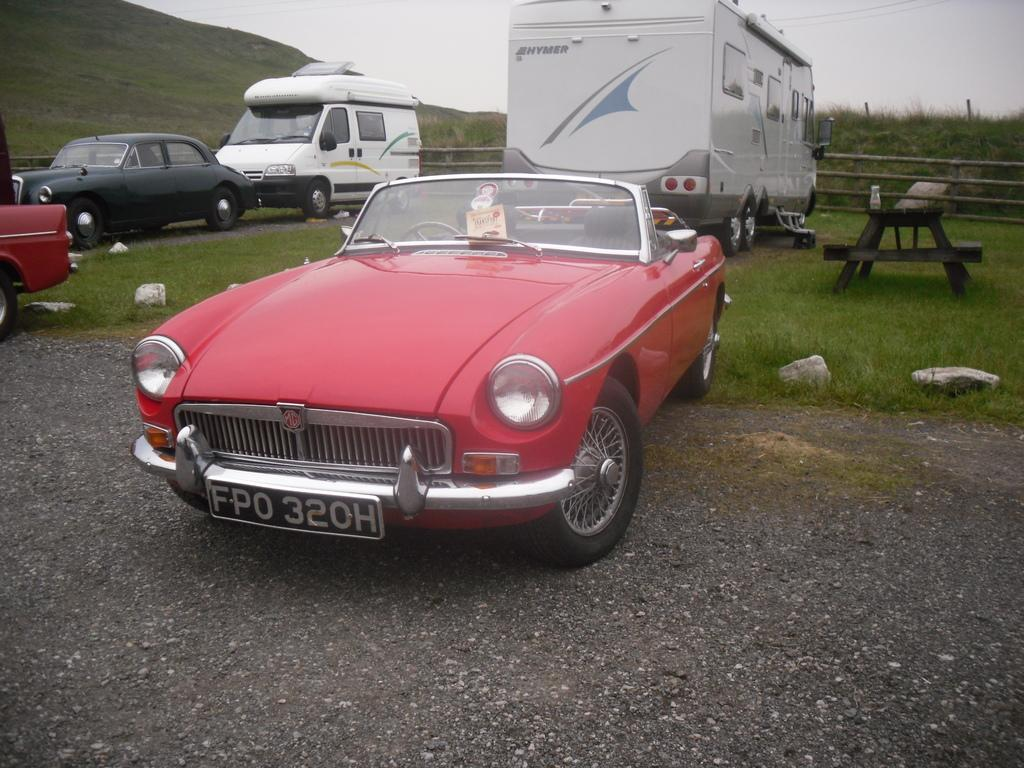What color is the car on the road in the image? The car on the road is red. What feature does the car have that allows it to move? The car has wheels. What can be seen in the distance beyond the car? There are vehicles in the distance. What type of furniture is on the grass in the image? There is a table and a bench on the grass. What is the landscape like in the background of the image? The mountain in the background is filled with grass. How does the car maintain its balance while driving on the road? The car does not need to maintain its balance while driving on the road, as it is designed to stay stable on its wheels. What type of system is responsible for the car's movement in the image? The car's movement is not explicitly mentioned in the image, so it is not possible to determine the system responsible for it. 